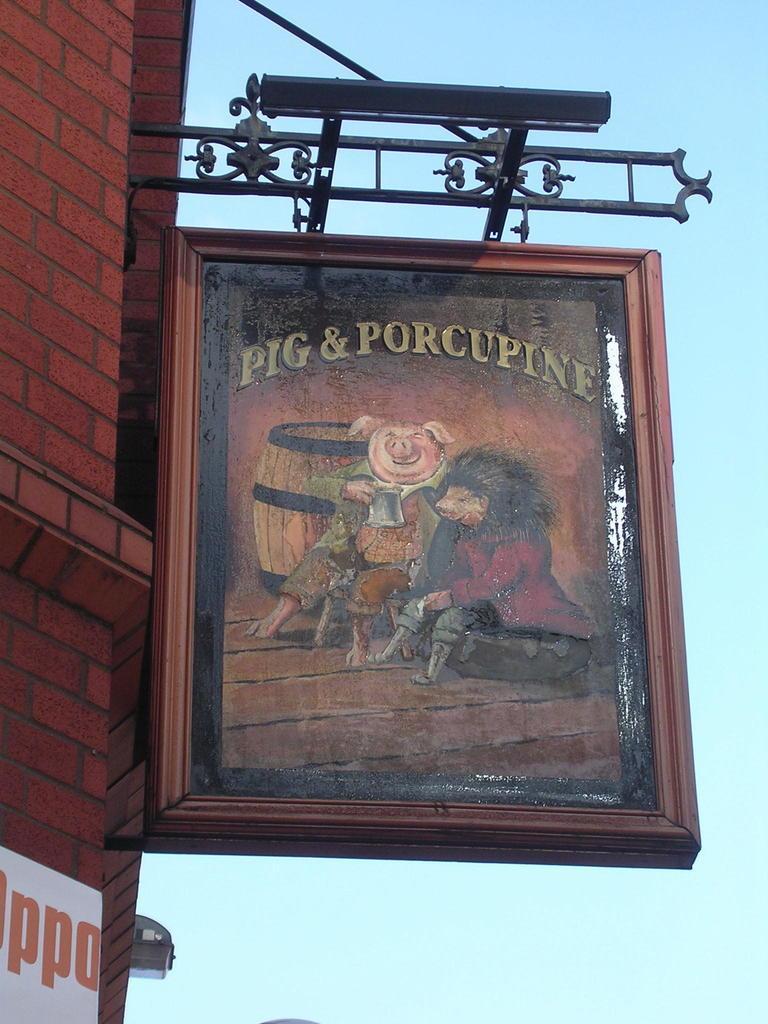Please provide a concise description of this image. In this image, we can see a board on the wall and there is a painting on the board, in the background we can see the sky. 